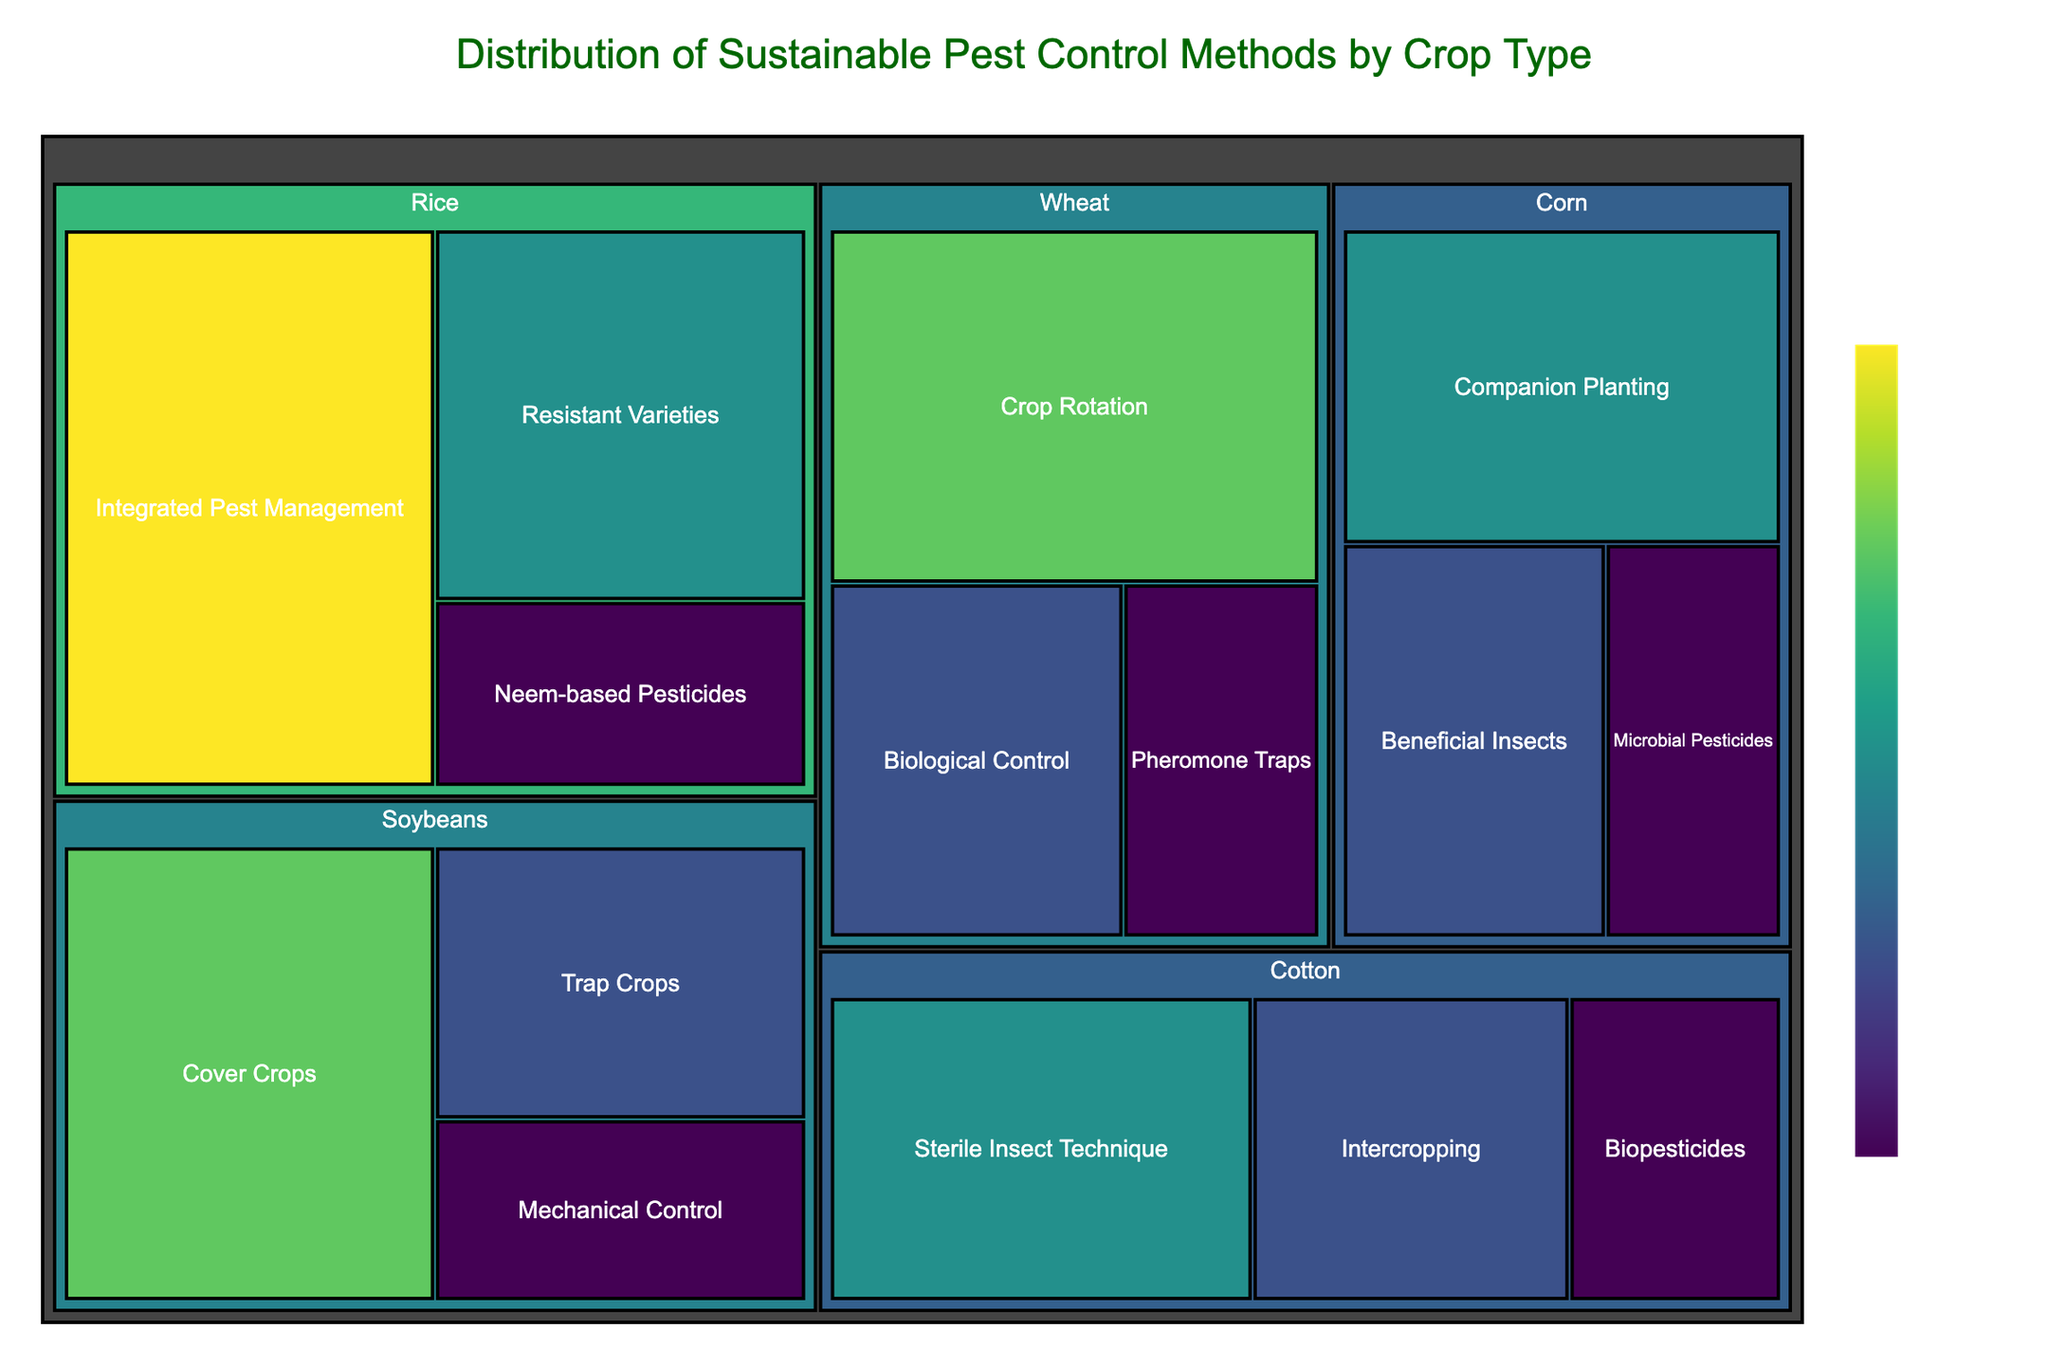What is the title of the treemap? The title of the treemap is located at the top center of the figure. It provides a quick indication of what the visualization is about.
Answer: Distribution of Sustainable Pest Control Methods by Crop Type What percentage is assigned to Crop Rotation for Wheat? By locating the Wheat section within the treemap and then finding the Crop Rotation subsection, the percentage value can be read directly.
Answer: 25% Which crop type has the highest individual method percentage, and what is that value? We search through each crop section for the highest percentage value. Rice's Integrated Pest Management method has the highest value.
Answer: 30% Compare the percentages of the sustainable pest control methods for Cotton. Which method has the smallest percentage? Viewing the Cotton section and comparing the percentages for each method: Sterile Insect Technique, Intercropping, and Biopesticides, Biopesticides has the smallest percentage.
Answer: Biopesticides with 10% What is the total percentage of Wheat for all its methods combined? Adding the percentages for all methods used for Wheat: Crop Rotation (25%), Biological Control (15%), and Pheromone Traps (10%). Sum these values to get the total percentage.
Answer: 50% Which pest control method has an equal percentage for two or more different crops, and what is the percentage? Looking for matching percentages across different crops, we find that Pheromone Traps for Wheat and Neem-based Pesticides for Rice both share the percentage value of 10%.
Answer: 10% What is the difference in percentage between Rice’s highest and lowest sustainable pest control methods? Subtract the lowest percentage (Neem-based Pesticides 10%) from the highest percentage (Integrated Pest Management 30%) within the Rice section.
Answer: 20% How does the use of Companion Planting in Corn compare to the use of Cover Crops in Soybeans in terms of percentage? Comparing percentages directly from their respective sections: Companion Planting in Corn (20%) and Cover Crops in Soybeans (25%).
Answer: Cover Crops in Soybeans has a higher percentage Based on the visualization, is there a crop method with an evenly distributed percentage among its methods? Checking each crop to see if any has methods with equal percentages. No crop has all its methods with equal distribution, for simplicity, Wheat is used as an example with values such as 25%, 15%, and 10%, which are not equal.
Answer: No Which sustainable pest control method is unique to Soybeans compared to other crops, and what is its percentage? Cross-referencing the methods listed for Soybeans (Cover Crops, Trap Crops, Mechanical Control) with other crops. Trap Crops is unique to Soybeans and its percentage is 15%.
Answer: Trap Crops with 15% 